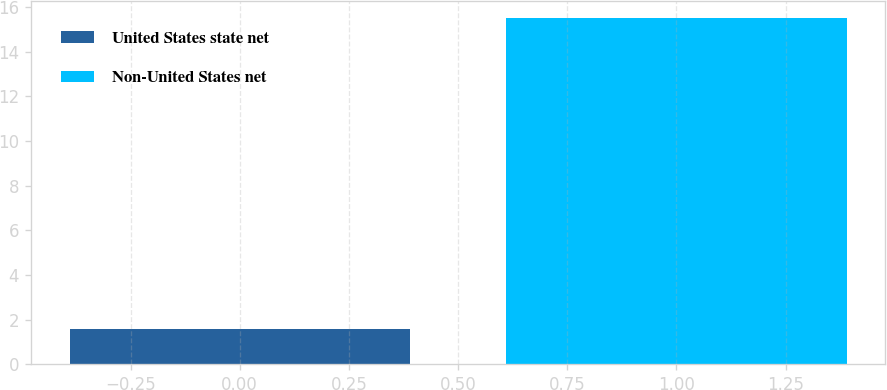<chart> <loc_0><loc_0><loc_500><loc_500><bar_chart><fcel>United States state net<fcel>Non-United States net<nl><fcel>1.6<fcel>15.5<nl></chart> 